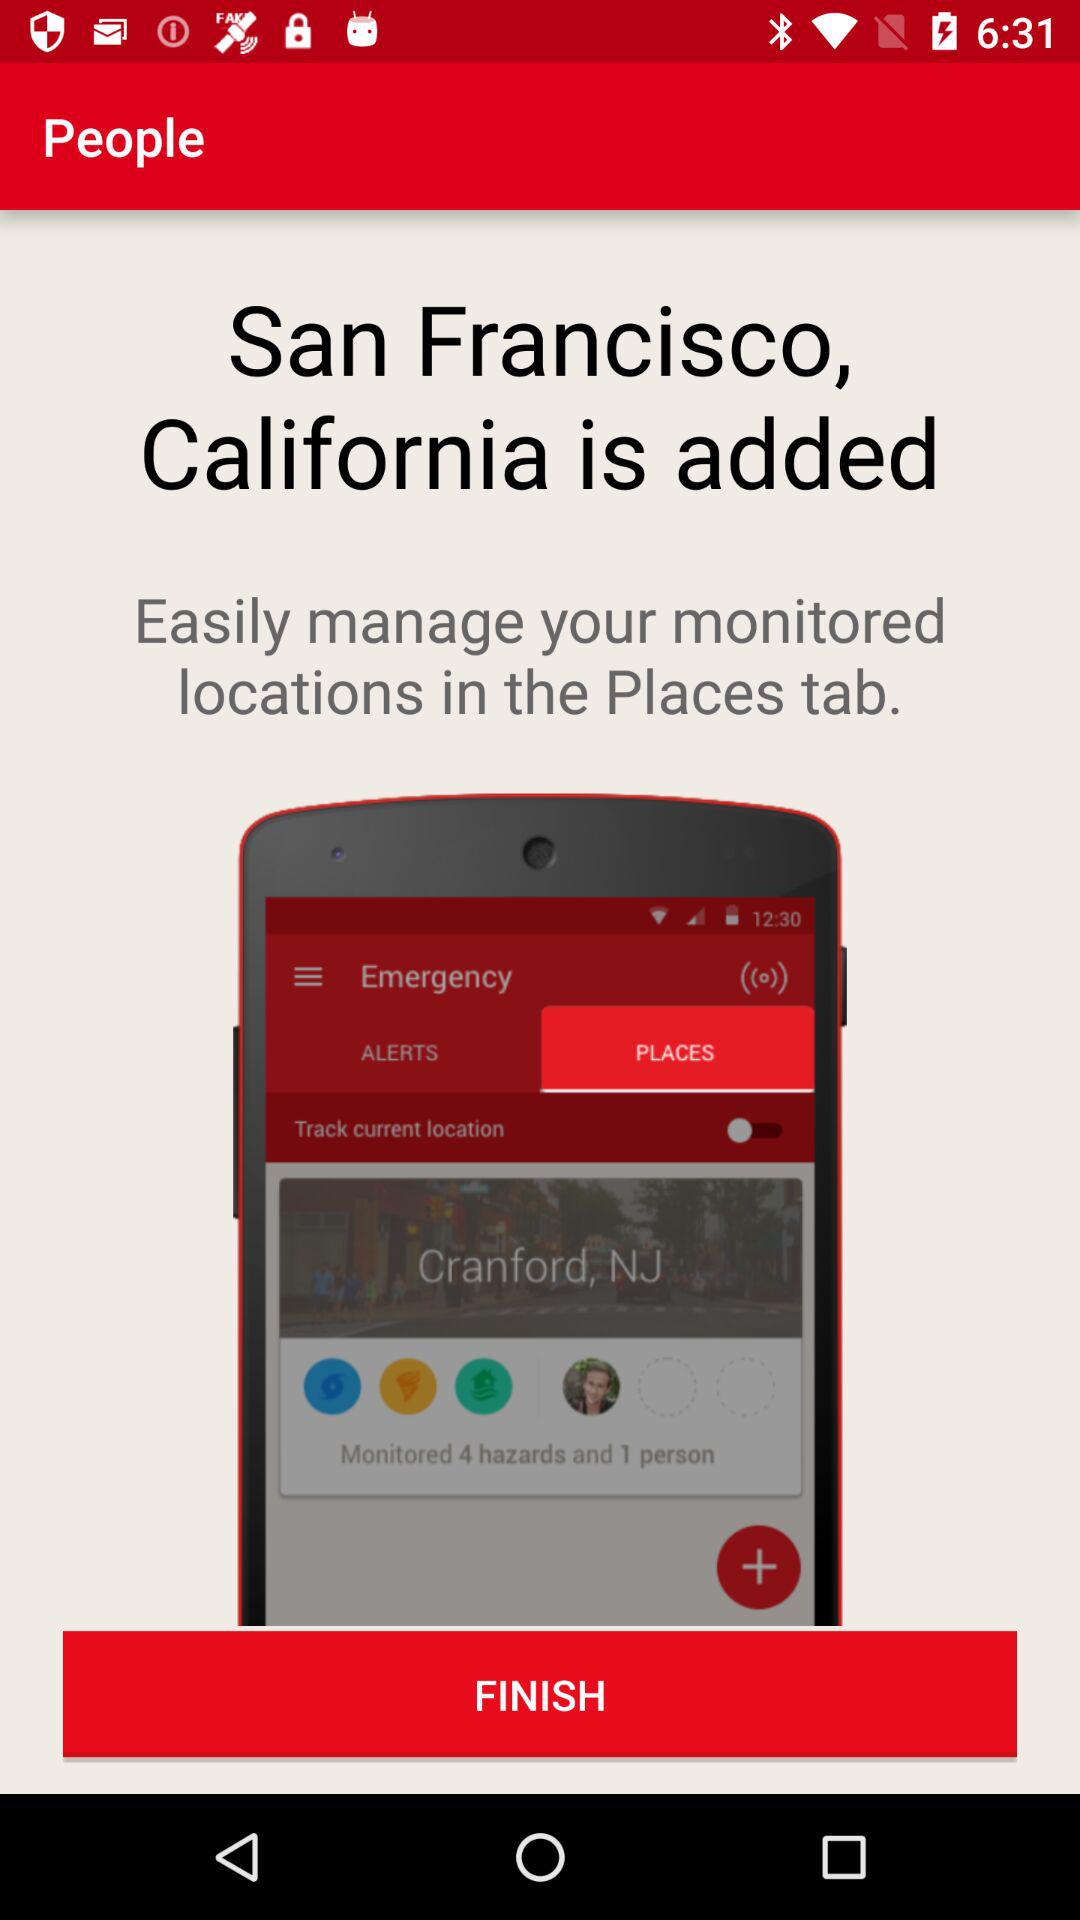Which city is mentioned? The mentioned city is San Francisco. 